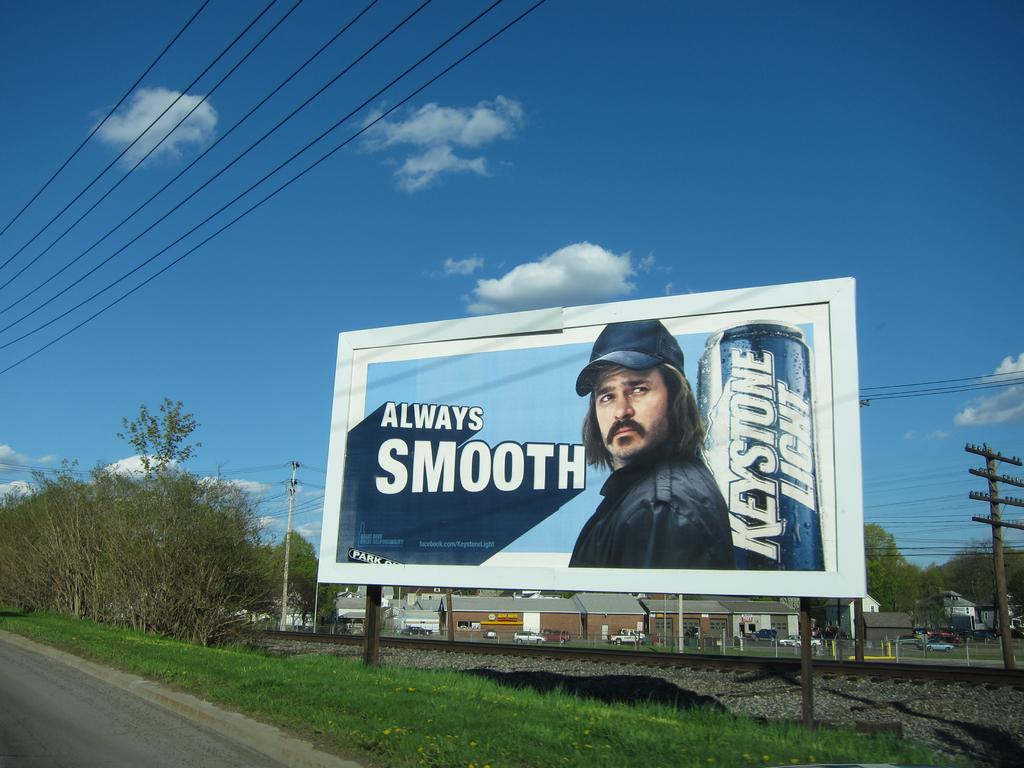<image>
Present a compact description of the photo's key features. A beer ad on a billboard advertising Keystone Light "Always Smooth". 